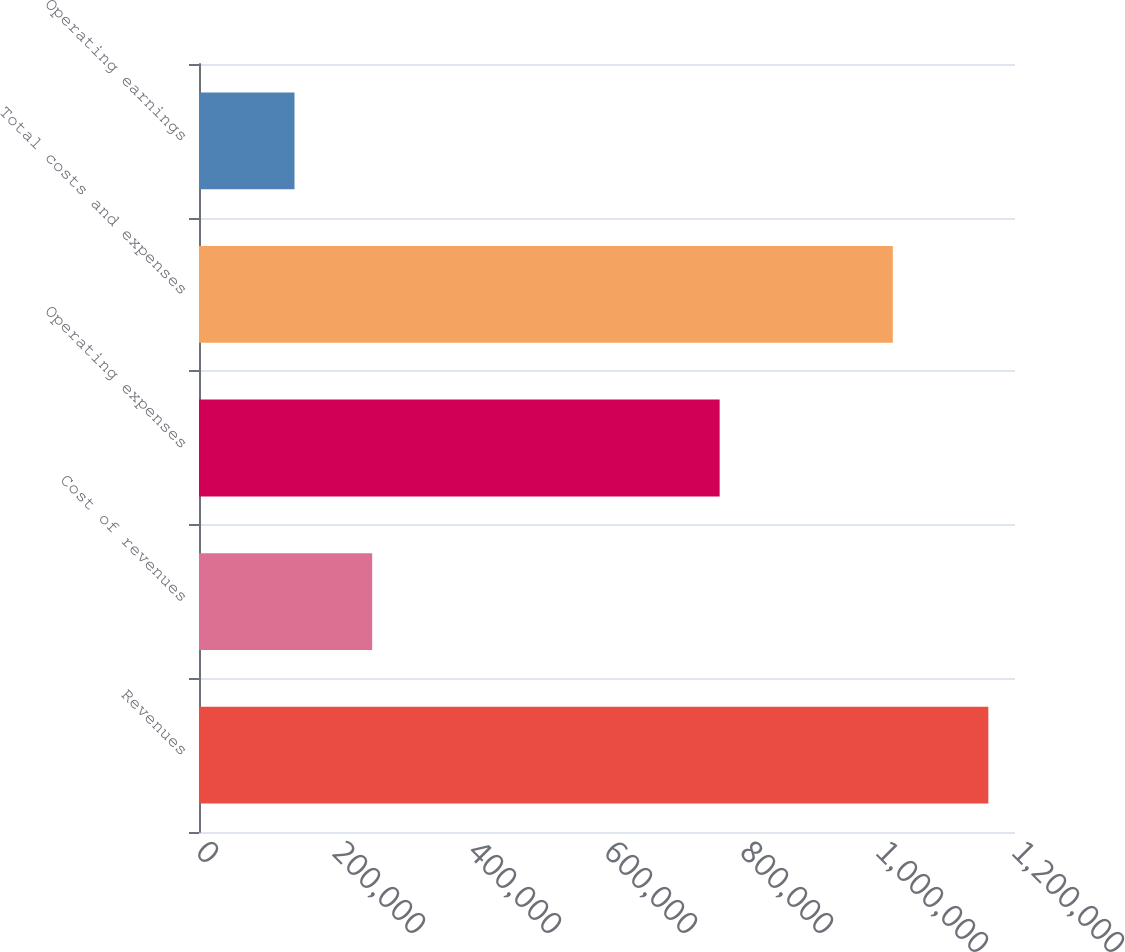<chart> <loc_0><loc_0><loc_500><loc_500><bar_chart><fcel>Revenues<fcel>Cost of revenues<fcel>Operating expenses<fcel>Total costs and expenses<fcel>Operating earnings<nl><fcel>1.16078e+06<fcel>254686<fcel>765663<fcel>1.02035e+06<fcel>140436<nl></chart> 